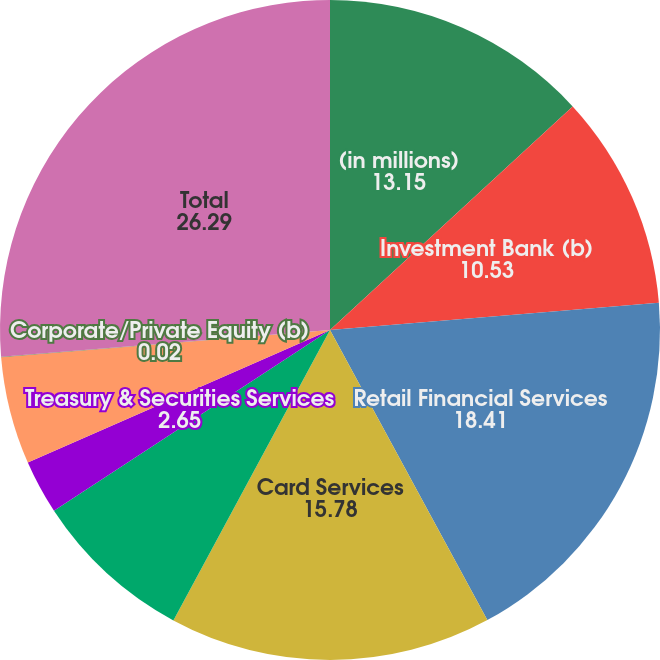Convert chart to OTSL. <chart><loc_0><loc_0><loc_500><loc_500><pie_chart><fcel>(in millions)<fcel>Investment Bank (b)<fcel>Retail Financial Services<fcel>Card Services<fcel>Commercial Banking<fcel>Treasury & Securities Services<fcel>Asset Management<fcel>Corporate/Private Equity (b)<fcel>Total<nl><fcel>13.15%<fcel>10.53%<fcel>18.41%<fcel>15.78%<fcel>7.9%<fcel>2.65%<fcel>5.27%<fcel>0.02%<fcel>26.29%<nl></chart> 